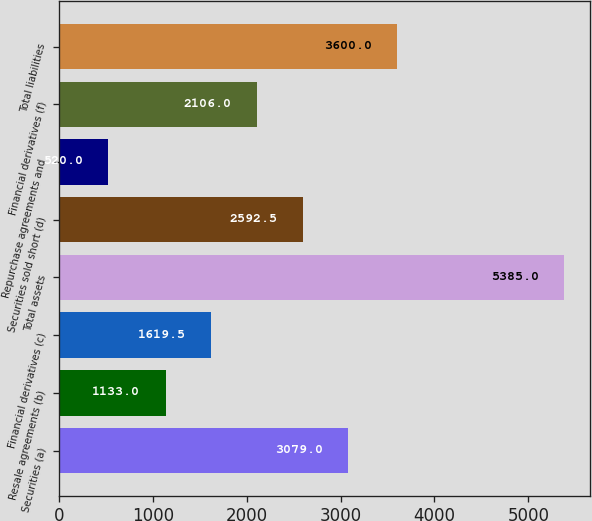Convert chart to OTSL. <chart><loc_0><loc_0><loc_500><loc_500><bar_chart><fcel>Securities (a)<fcel>Resale agreements (b)<fcel>Financial derivatives (c)<fcel>Total assets<fcel>Securities sold short (d)<fcel>Repurchase agreements and<fcel>Financial derivatives (f)<fcel>Total liabilities<nl><fcel>3079<fcel>1133<fcel>1619.5<fcel>5385<fcel>2592.5<fcel>520<fcel>2106<fcel>3600<nl></chart> 